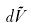Convert formula to latex. <formula><loc_0><loc_0><loc_500><loc_500>d \tilde { V }</formula> 